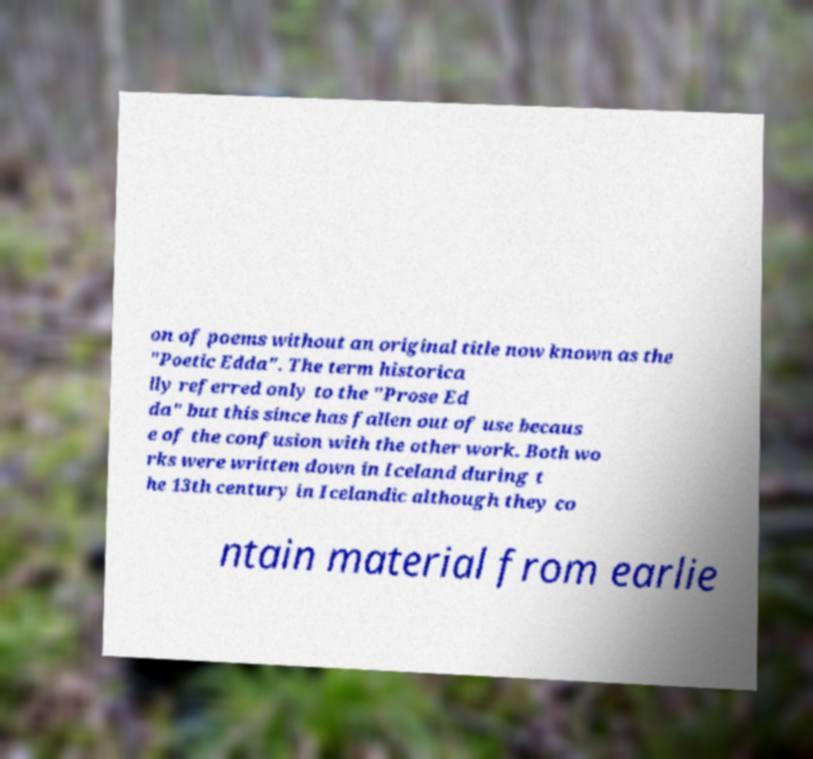Please identify and transcribe the text found in this image. on of poems without an original title now known as the "Poetic Edda". The term historica lly referred only to the "Prose Ed da" but this since has fallen out of use becaus e of the confusion with the other work. Both wo rks were written down in Iceland during t he 13th century in Icelandic although they co ntain material from earlie 